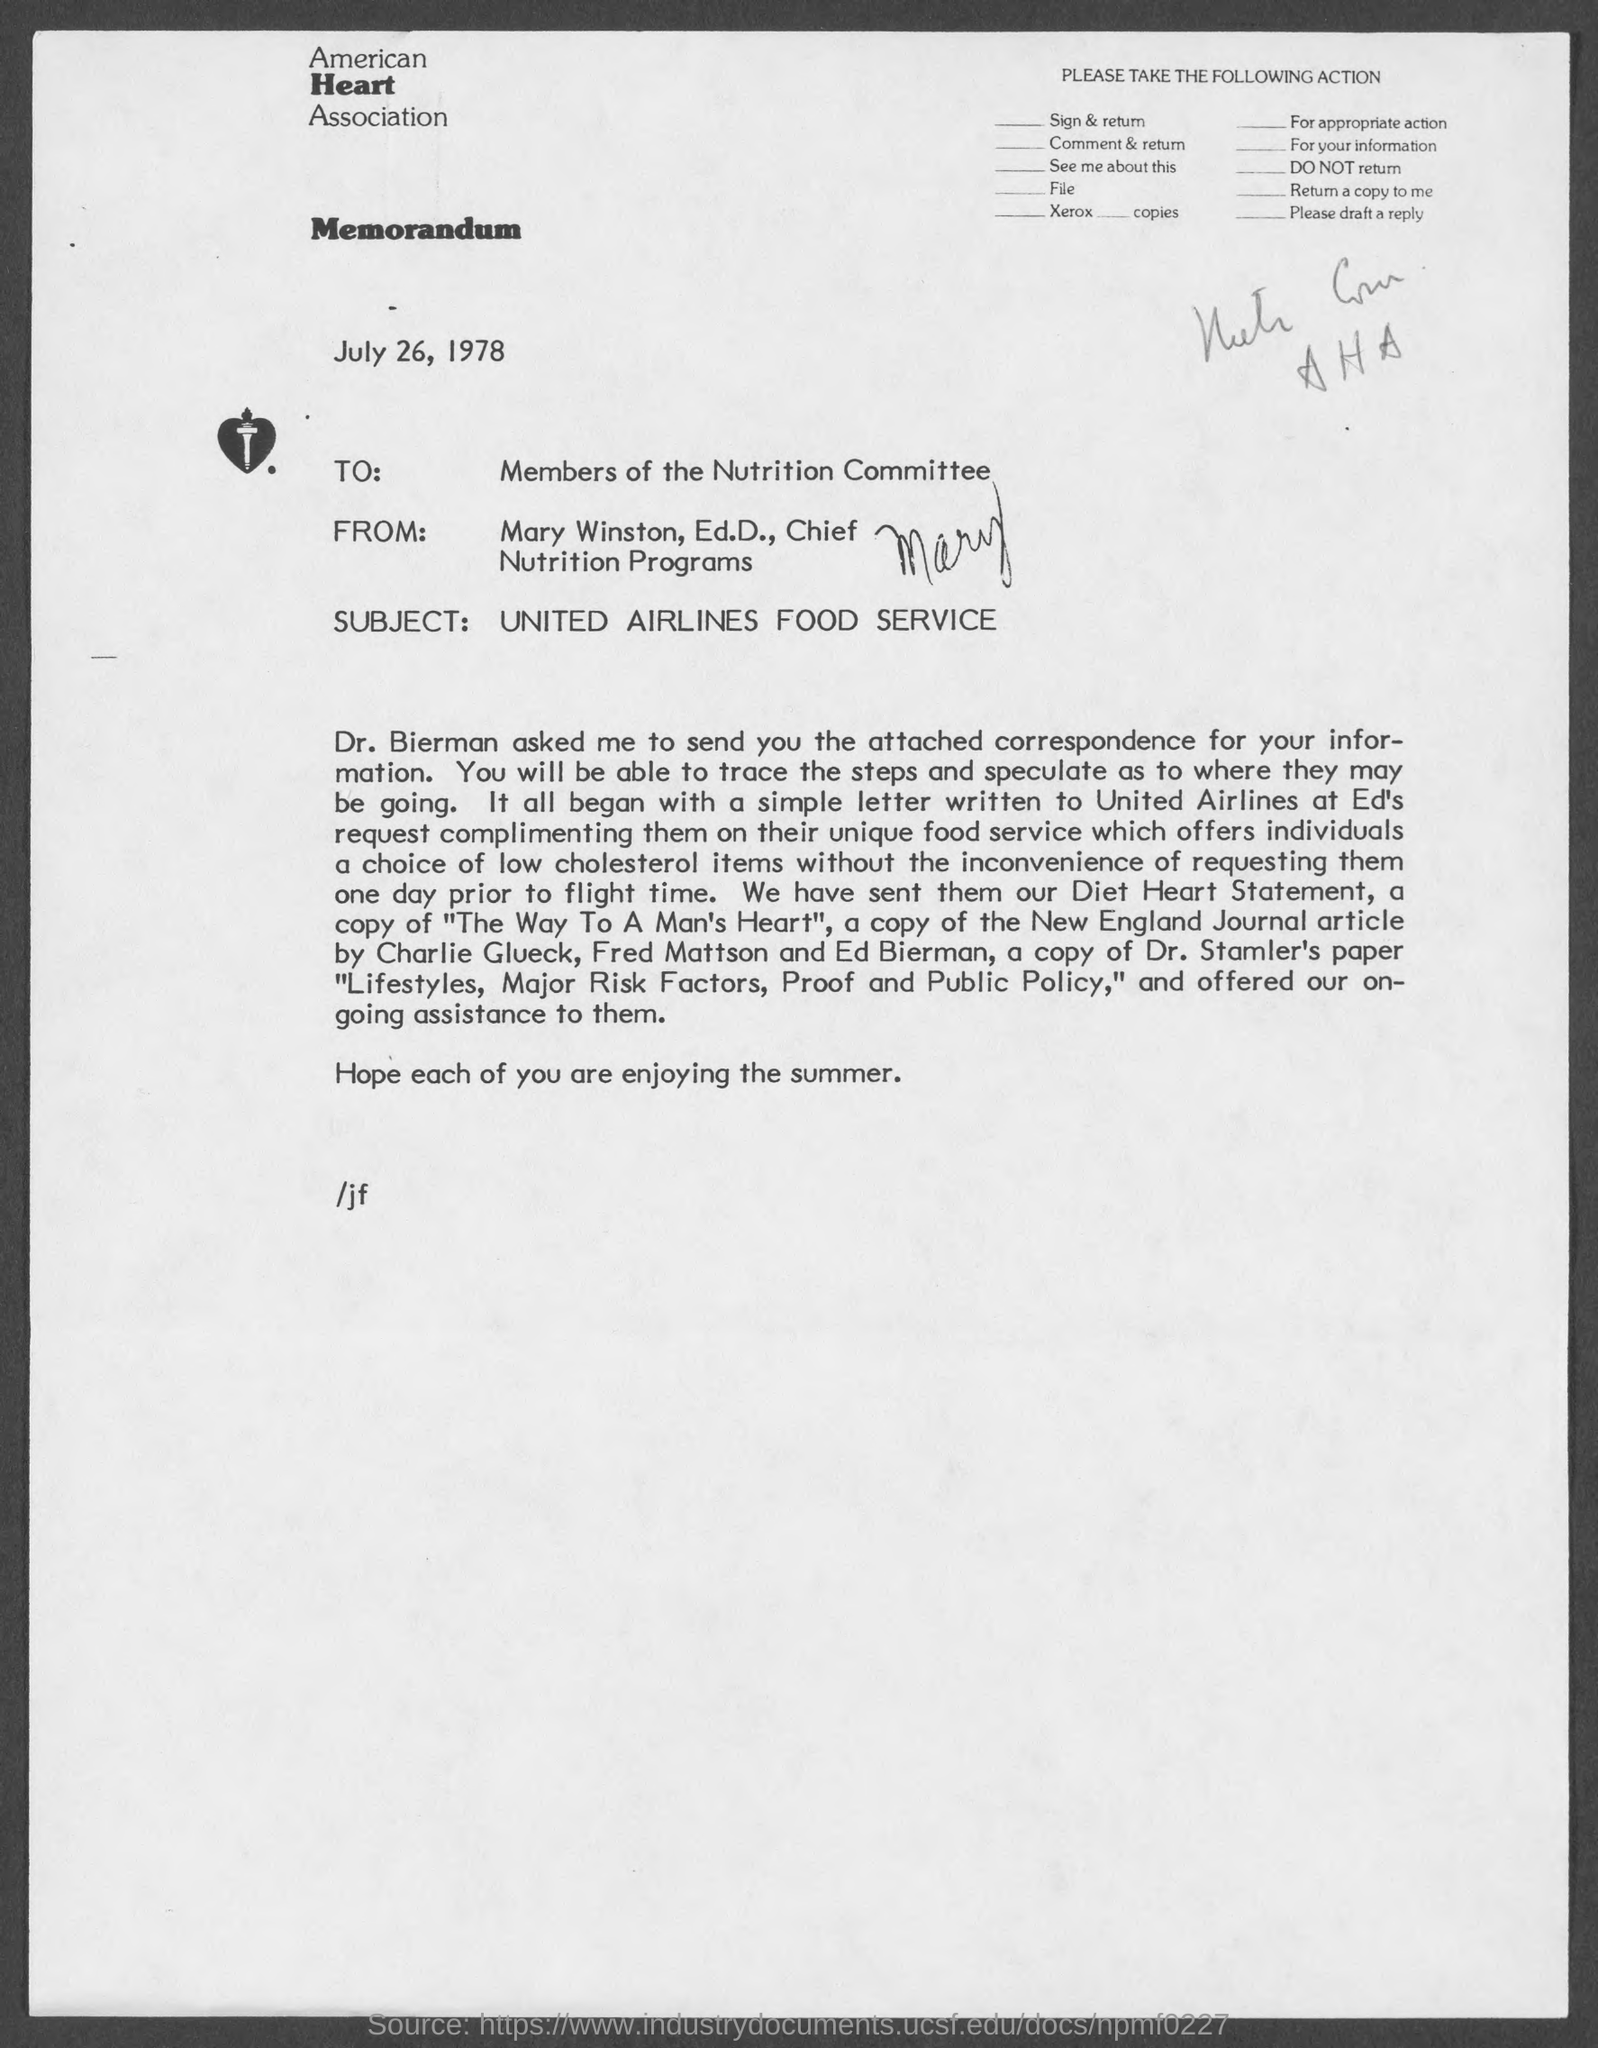Outline some significant characteristics in this image. The subject of the memorandum is United Airlines Food Service. The date mentioned in the memorandum is July 26, 1978. This is a memorandum, which is a type of communication. The memorandum is addressed to the members of the Nutrition Committee. The letterhead contains a reference to the American Heart Association. 